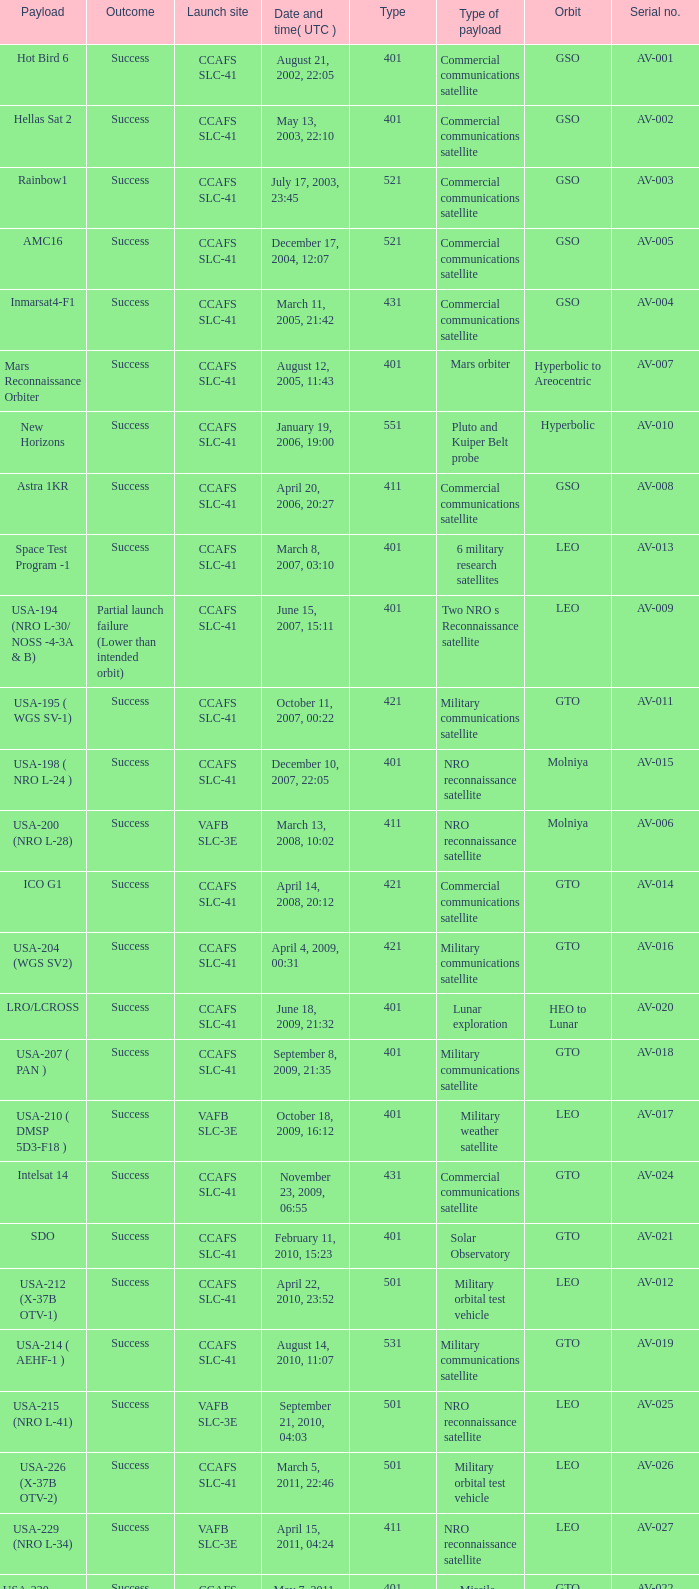When was the payload of Commercial Communications Satellite amc16? December 17, 2004, 12:07. 